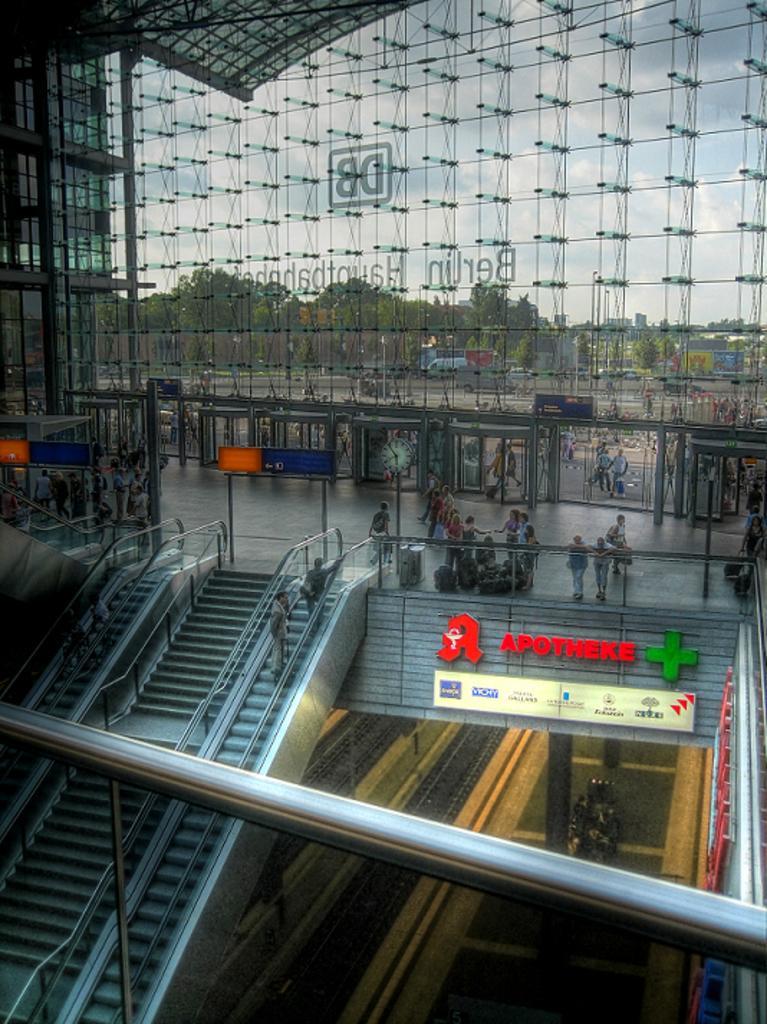How would you summarize this image in a sentence or two? In this image we can see escalators and stairs with railings. Also there are people. In the back we can see glass wall with text. Also there are pillars. In the background we can see trees and sky. And there are entrances and boards. On the board there is text. 